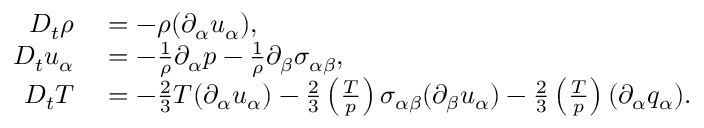<formula> <loc_0><loc_0><loc_500><loc_500>\begin{array} { r l } { D _ { t } \rho } & = - \rho ( \partial _ { \alpha } u _ { \alpha } ) , } \\ { D _ { t } u _ { \alpha } } & = - \frac { 1 } { \rho } \partial _ { \alpha } p - \frac { 1 } { \rho } \partial _ { \beta } { \sigma } _ { \alpha \beta } , } \\ { D _ { t } T } & = - \frac { 2 } { 3 } T ( \partial _ { \alpha } u _ { \alpha } ) - \frac { 2 } { 3 } \left ( \frac { T } { p } \right ) \sigma _ { \alpha \beta } ( \partial _ { \beta } u _ { \alpha } ) - \frac { 2 } { 3 } \left ( \frac { T } { p } \right ) ( \partial _ { \alpha } q _ { \alpha } ) . } \end{array}</formula> 